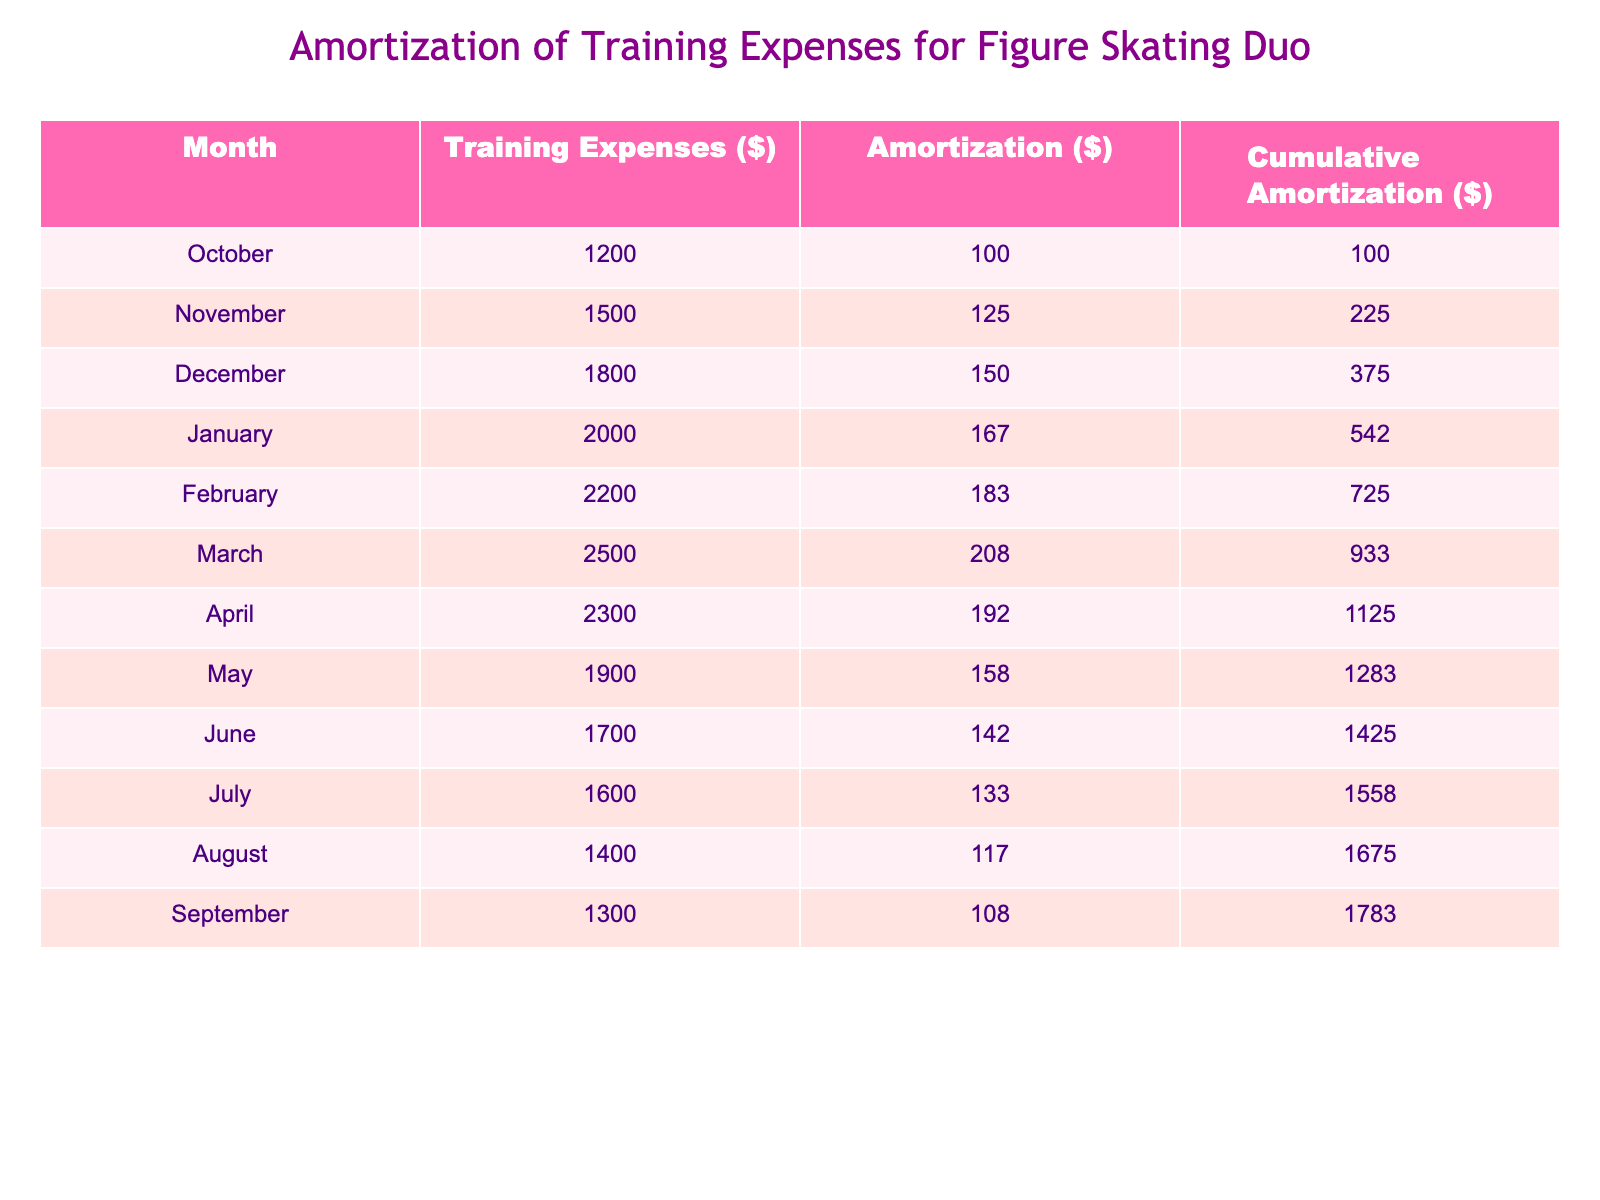What are the total training expenses for the month of January? The training expense for January is listed in the table as 2000 dollars.
Answer: 2000 What is the amortization amount for the month of March? The amortization for March is explicitly stated in the table as 208 dollars.
Answer: 208 What is the cumulative amortization for the month of June? To find the cumulative amortization for June, we look at the corresponding value in the table, which is 1425 dollars.
Answer: 1425 Which month had the highest training expenses? The month with the highest training expenses is March, at 2500 dollars, as per the amount listed in the training expenses column.
Answer: March What is the average training expense over the season? To calculate the average training expense, we sum all monthly expenses: 1200 + 1500 + 1800 + 2000 + 2200 + 2500 + 2300 + 1900 + 1700 + 1600 + 1400 + 1300 =  22800 dollars. Then, divide by the number of months (12), which gives us an average of 1900 dollars.
Answer: 1900 Is the cumulative amortization for April greater than the amortization for January? The cumulative amortization for April is 1125 dollars and for January is 542 dollars. Since 1125 is greater than 542, the answer is yes.
Answer: Yes What is the difference in cumulative amortization between February and June? The cumulative amortization for February is 725 dollars, and for June, it is 1425 dollars. To find the difference, we subtract: 1425 - 725 = 700 dollars.
Answer: 700 In which month is the amortization amount closest to 150 dollars? The closest amortization amount to 150 dollars in the table is December, where it is exactly 150 dollars.
Answer: December What was the total training expense from October to March? We sum the monthly training expenses from October (1200) to March (2500): 1200 + 1500 + 1800 + 2000 + 2200 + 2500 = 12200 dollars.
Answer: 12200 